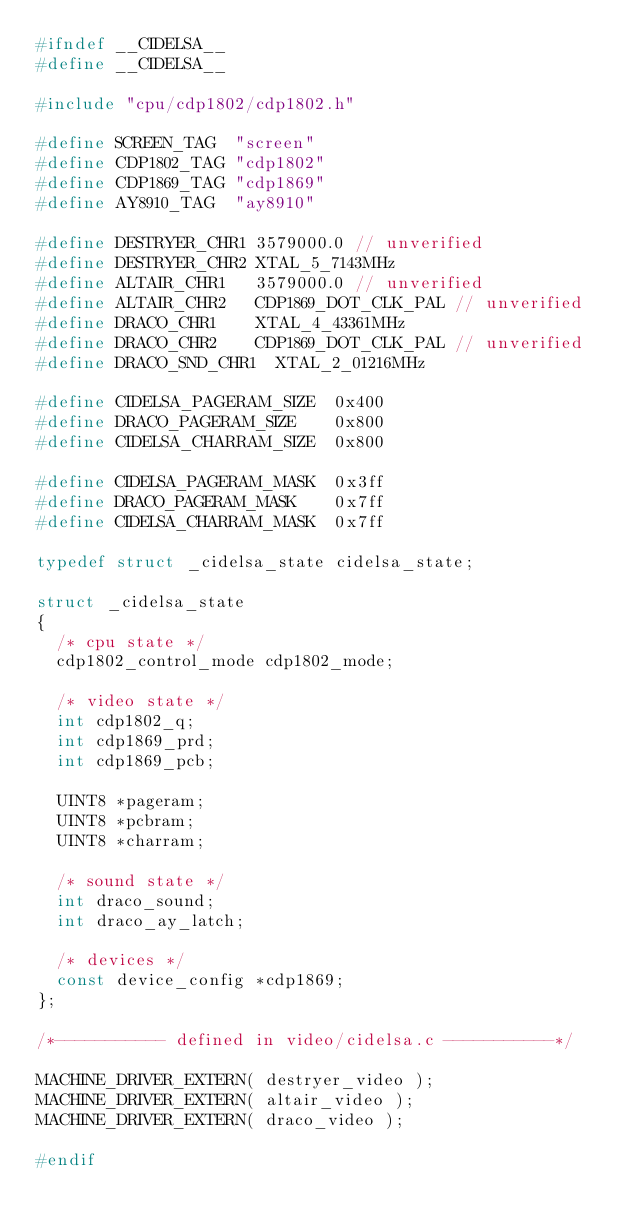<code> <loc_0><loc_0><loc_500><loc_500><_C_>#ifndef __CIDELSA__
#define __CIDELSA__

#include "cpu/cdp1802/cdp1802.h"

#define SCREEN_TAG	"screen"
#define CDP1802_TAG	"cdp1802"
#define CDP1869_TAG	"cdp1869"
#define AY8910_TAG	"ay8910"

#define DESTRYER_CHR1	3579000.0 // unverified
#define DESTRYER_CHR2	XTAL_5_7143MHz
#define ALTAIR_CHR1		3579000.0 // unverified
#define ALTAIR_CHR2		CDP1869_DOT_CLK_PAL // unverified
#define DRACO_CHR1		XTAL_4_43361MHz
#define DRACO_CHR2		CDP1869_DOT_CLK_PAL // unverified
#define DRACO_SND_CHR1	XTAL_2_01216MHz

#define CIDELSA_PAGERAM_SIZE	0x400
#define DRACO_PAGERAM_SIZE		0x800
#define CIDELSA_CHARRAM_SIZE	0x800

#define CIDELSA_PAGERAM_MASK	0x3ff
#define DRACO_PAGERAM_MASK		0x7ff
#define CIDELSA_CHARRAM_MASK	0x7ff

typedef struct _cidelsa_state cidelsa_state;

struct _cidelsa_state
{
	/* cpu state */
	cdp1802_control_mode cdp1802_mode;

	/* video state */
	int cdp1802_q;
	int cdp1869_prd;
	int cdp1869_pcb;

	UINT8 *pageram;
	UINT8 *pcbram;
	UINT8 *charram;

	/* sound state */
	int draco_sound;
	int draco_ay_latch;

	/* devices */
	const device_config *cdp1869;
};

/*----------- defined in video/cidelsa.c -----------*/

MACHINE_DRIVER_EXTERN( destryer_video );
MACHINE_DRIVER_EXTERN( altair_video );
MACHINE_DRIVER_EXTERN( draco_video );

#endif
</code> 